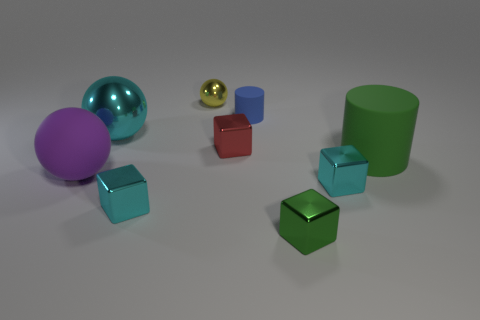Are there more tiny green cubes to the right of the small rubber object than tiny metallic balls on the right side of the green metallic cube?
Offer a terse response. Yes. What number of objects are rubber balls or green cylinders?
Your answer should be very brief. 2. What number of other things are the same color as the large metallic sphere?
Your answer should be compact. 2. There is a purple matte thing that is the same size as the cyan sphere; what shape is it?
Ensure brevity in your answer.  Sphere. What color is the large sphere that is in front of the green rubber cylinder?
Your response must be concise. Purple. How many things are large objects on the right side of the red thing or small cyan shiny objects on the right side of the small yellow metal ball?
Your answer should be very brief. 2. Do the purple sphere and the green cylinder have the same size?
Your answer should be compact. Yes. How many cubes are tiny things or big green things?
Offer a very short reply. 4. What number of cyan objects are behind the big purple matte thing and to the right of the big cyan ball?
Your response must be concise. 0. Do the yellow thing and the cyan metallic block to the right of the yellow metallic thing have the same size?
Make the answer very short. Yes. 